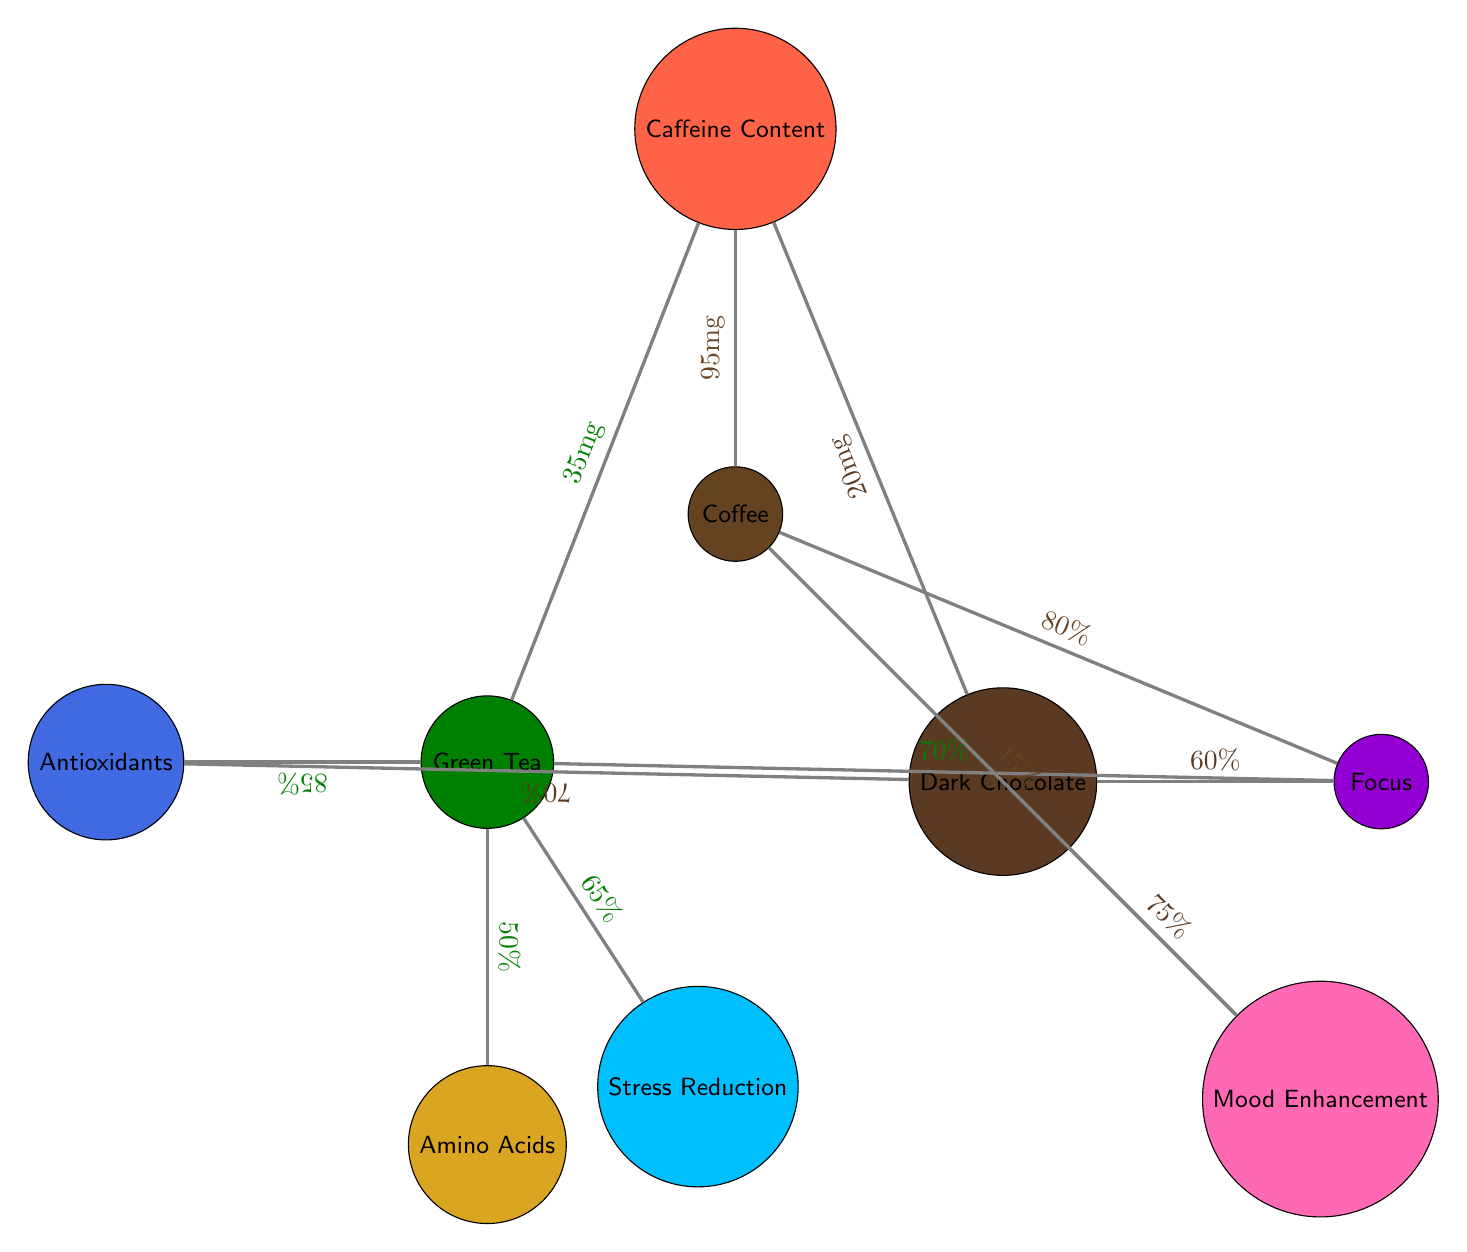What is the caffeine content in Coffee? The diagram shows a direct connection from the Coffee node to the Caffeine Content node with a label indicating the caffeine amount as 95 mg per cup.
Answer: 95 mg Which caffeine source has the lowest caffeine content? By comparing the caffeine content values from the connections, Dark Chocolate has 20 mg, which is lower than both Coffee (95 mg) and Green Tea (35 mg).
Answer: Dark Chocolate What percentage impact on Focus does Green Tea have? The diagram directly indicates a connection from Green Tea to Focus, showing a value of 70%, which represents the percentage effectiveness in impacting focus.
Answer: 70% Which food has the highest Mood Enhancement effect? The diagram shows connections to the Mood Enhancement node. Dark Chocolate has a value of 75%, while Coffee has a value of 45%. Therefore, Dark Chocolate is the food with the highest impact.
Answer: Dark Chocolate What relationship exists between Green Tea and Antioxidants? There is a connection from Green Tea to the Antioxidants node, indicating that Green Tea positively contributes to the antioxidants level with a value of 85%.
Answer: 85% What is the total number of nodes in the diagram? The total number of nodes in the diagram includes Coffee, Green Tea, Dark Chocolate, Caffeine Content, Antioxidants, Amino Acids, Focus, Stress Reduction, and Mood Enhancement, making a total of 8 nodes.
Answer: 8 Which source has an associated value for Stress Reduction? The diagram shows a connection from Green Tea to Stress Reduction, indicating that Green Tea is associated with this effect at a value of 65%.
Answer: Green Tea Which node has the least amount of connection? Analyzing the connections, Coffee only connects to Caffeine Content, Focus, and Mood Enhancement, totaling 3 connections. Dark Chocolate also has 3 connections but has a higher Mood Enhancement value. Therefore, both Coffee and Dark Chocolate have the least.
Answer: Coffee and Dark Chocolate What node has the highest percentage in the Focus category? Comparing the values connected to the Focus node, Coffee (80%) has the highest percentage impact on Focus compared to Green Tea (70%) and Dark Chocolate (60%).
Answer: Coffee 